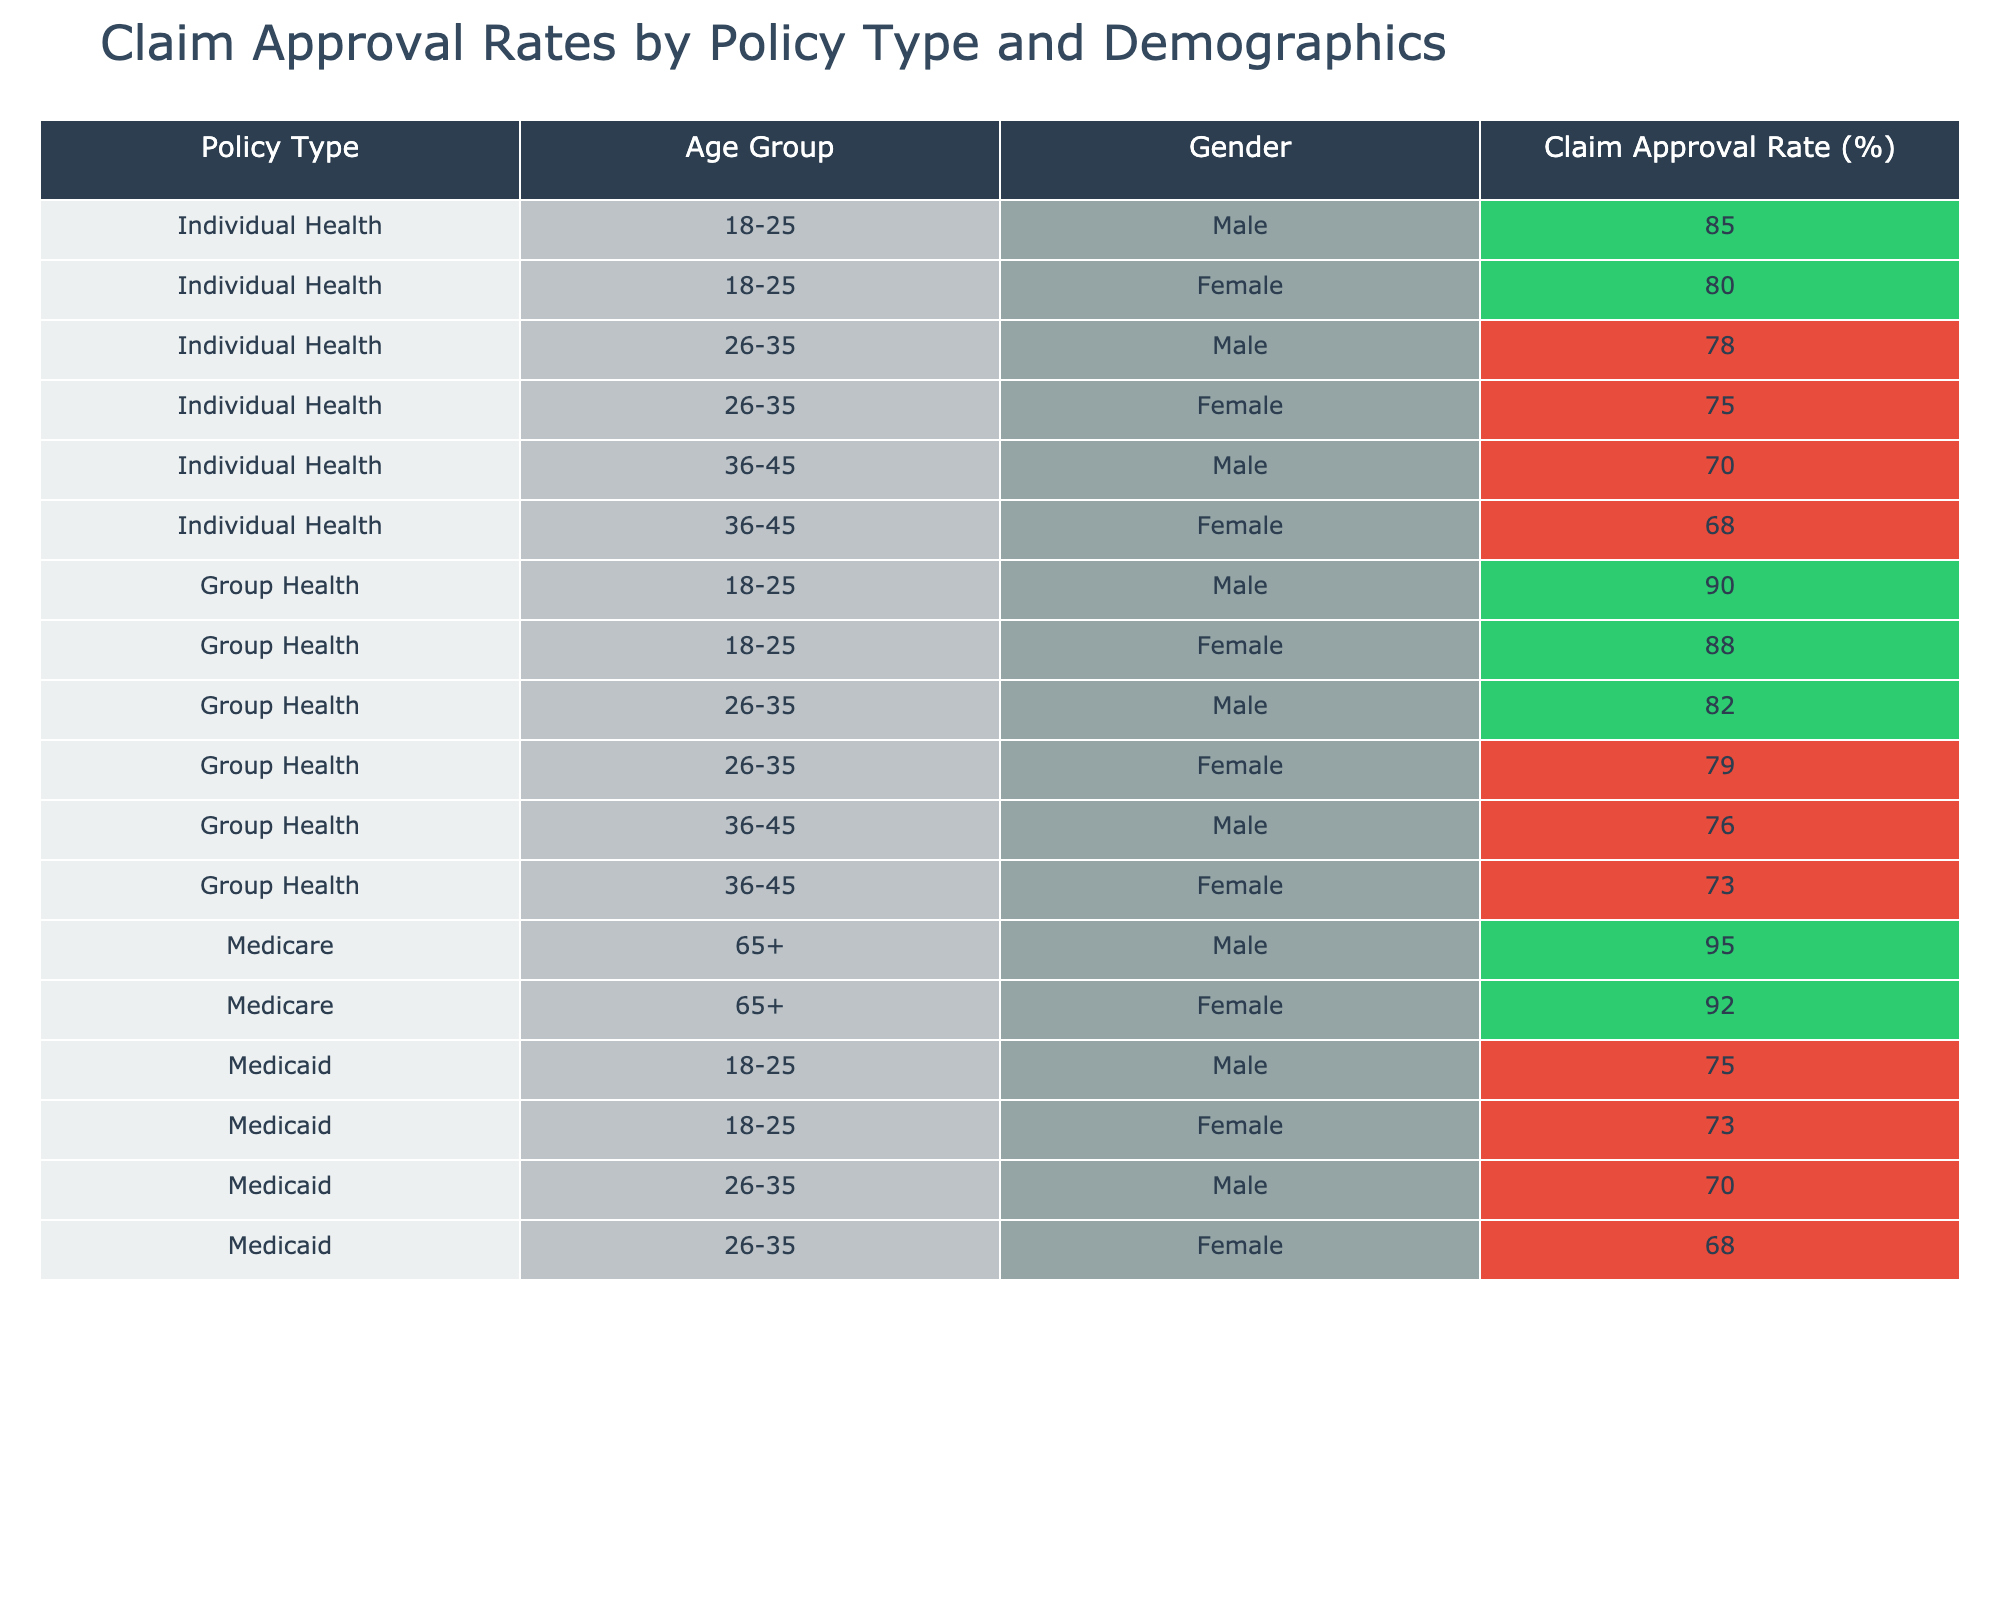What is the claim approval rate for Medicare claims for females aged 65 and older? The table shows a claim approval rate of 92% for Medicare claims specifically for females in the 65+ age group.
Answer: 92% Which age group has the highest claim approval rate for Group Health policies? The highest claim approval rate for Group Health policies is 90% for the 18-25 age group, which applies to both males and females in that category.
Answer: 90% What is the average claim approval rate for Female Individual Health policyholders across all age groups? The approval rates for females in Individual Health are 80%, 75%, 68%. Summing these gives 80 + 75 + 68 = 223, and dividing by 3 gives an average of 223/3 = 74.33, rounded to 74%.
Answer: 74% Are male policyholders in the 26-35 age group more likely to have their claims approved under Group Health or Individual Health? The table shows a claim approval rate of 82% for males in the 26-35 age group under Group Health and 78% for Individual Health. Since 82% > 78%, males in this age group have a higher approval rate under Group Health.
Answer: Yes What is the difference in claim approval rates between Medicare and Medicaid claims for males aged 18-25? The claim approval rate for males in the 18-25 age group under Medicare is not applicable, as these policies are not listed for this demographic. The rate for Medicaid is 75%. Therefore, the difference cannot be determined against Medicare.
Answer: N/A What is the lowest claim approval rate across all policy types and demographics? Upon reviewing the table, the lowest claim approval rate is 68% for females aged 26-35 under Medicaid policies.
Answer: 68% How many demographic segments show a claim approval rate of less than 80% for Individual Health policies? Looking at Individual Health policies, the age groups 36-45 (70% for males, 68% for females) show rates below 80%. Therefore, there are 4 segments (two males and two females in 36-45) with rates below 80%.
Answer: 4 Is there a significant difference between the claim approval rates for males and females aged 36-45 under Individual Health policies? For males in that age group, the approval rate is 70%, while for females, it's 68%. The difference is slight and can be considered insignificant in this context.
Answer: No 